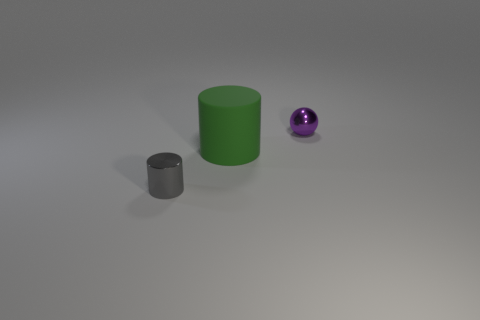Add 3 green rubber objects. How many objects exist? 6 Subtract all balls. How many objects are left? 2 Add 2 metallic objects. How many metallic objects are left? 4 Add 1 cyan metal things. How many cyan metal things exist? 1 Subtract 0 blue cubes. How many objects are left? 3 Subtract all small gray cylinders. Subtract all gray spheres. How many objects are left? 2 